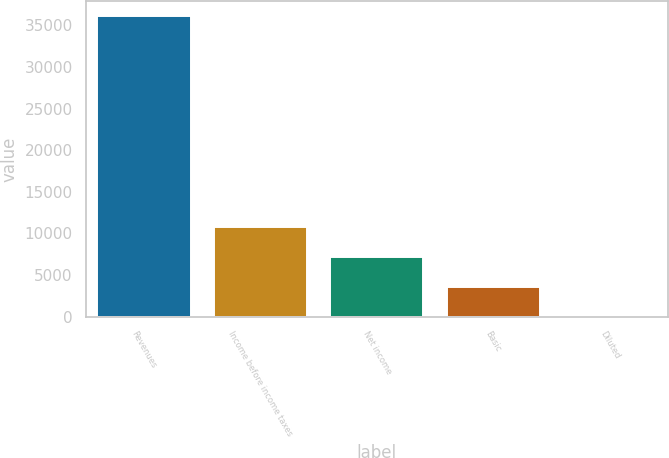Convert chart. <chart><loc_0><loc_0><loc_500><loc_500><bar_chart><fcel>Revenues<fcel>Income before income taxes<fcel>Net income<fcel>Basic<fcel>Diluted<nl><fcel>36079<fcel>10823.9<fcel>7216.04<fcel>3608.17<fcel>0.3<nl></chart> 